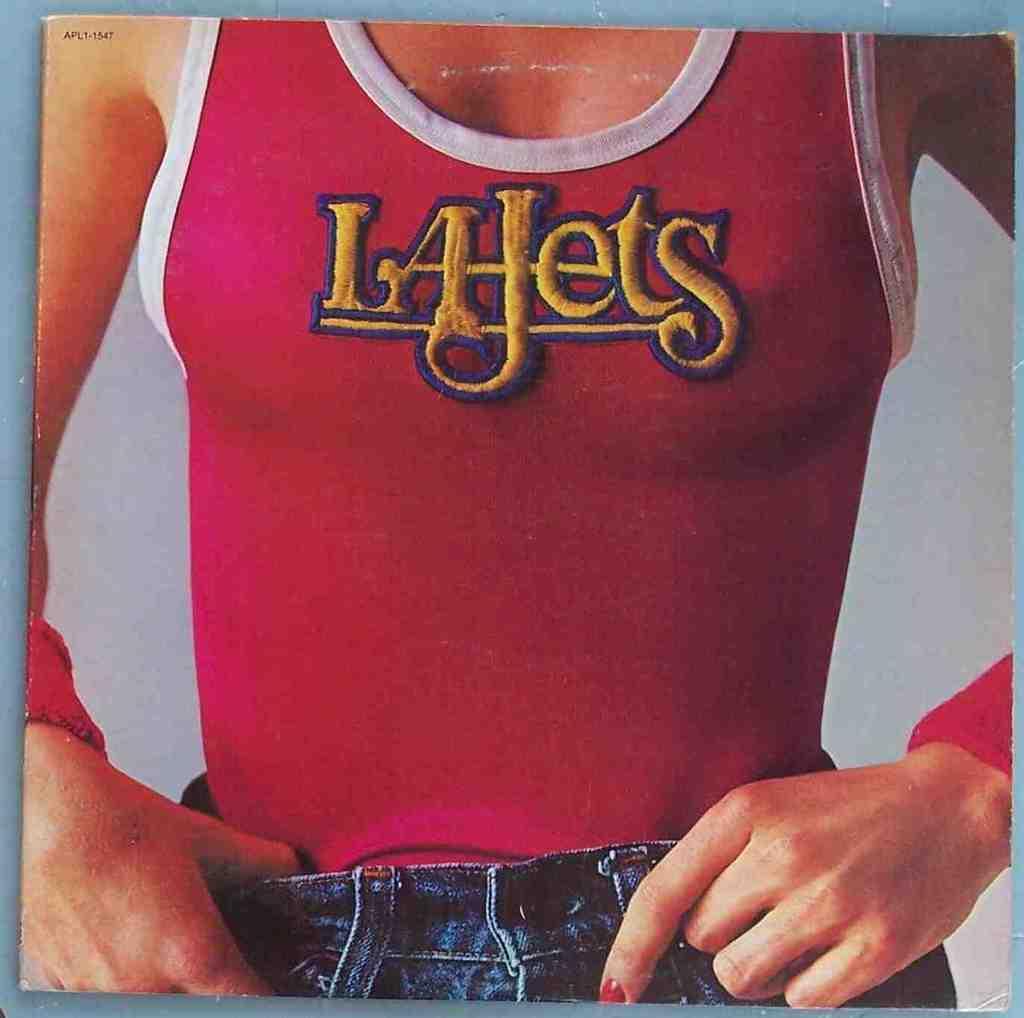In one or two sentences, can you explain what this image depicts? In this picture we can see a woman, this woman wore a vest and jeans, we can see a plane background. 